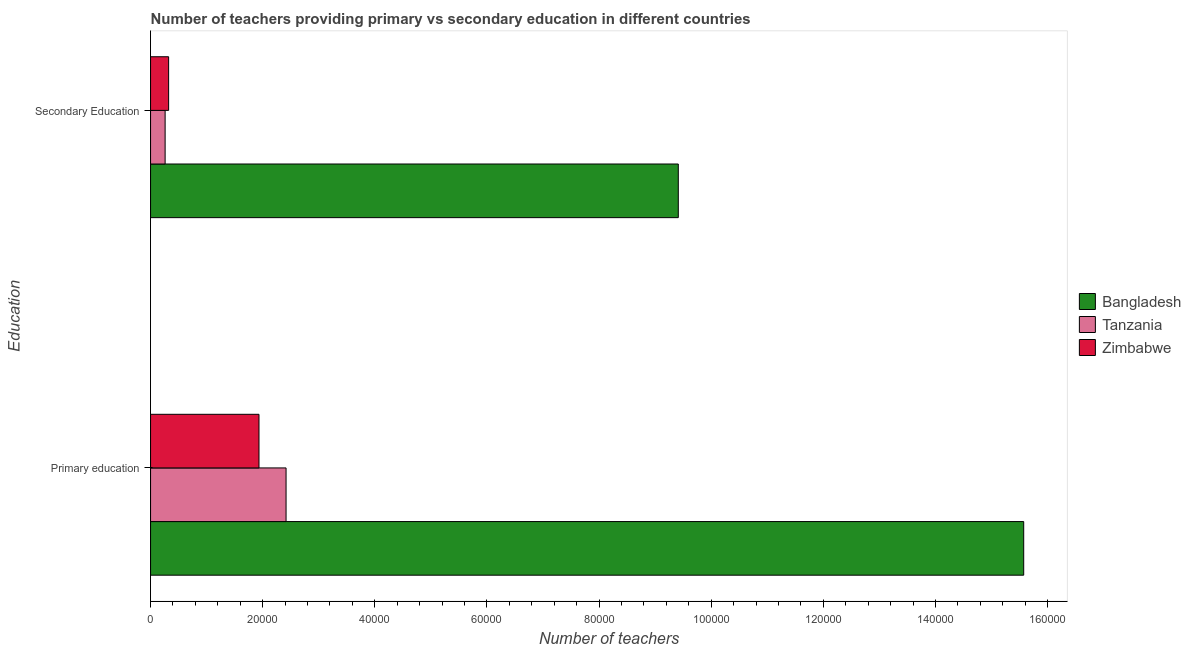How many different coloured bars are there?
Ensure brevity in your answer.  3. How many groups of bars are there?
Provide a succinct answer. 2. Are the number of bars on each tick of the Y-axis equal?
Give a very brief answer. Yes. What is the label of the 1st group of bars from the top?
Offer a very short reply. Secondary Education. What is the number of secondary teachers in Tanzania?
Ensure brevity in your answer.  2596. Across all countries, what is the maximum number of secondary teachers?
Provide a succinct answer. 9.41e+04. Across all countries, what is the minimum number of primary teachers?
Your response must be concise. 1.93e+04. In which country was the number of secondary teachers minimum?
Provide a short and direct response. Tanzania. What is the total number of secondary teachers in the graph?
Make the answer very short. 9.99e+04. What is the difference between the number of primary teachers in Tanzania and that in Bangladesh?
Make the answer very short. -1.32e+05. What is the difference between the number of secondary teachers in Zimbabwe and the number of primary teachers in Tanzania?
Make the answer very short. -2.09e+04. What is the average number of secondary teachers per country?
Keep it short and to the point. 3.33e+04. What is the difference between the number of secondary teachers and number of primary teachers in Tanzania?
Provide a succinct answer. -2.16e+04. What is the ratio of the number of primary teachers in Bangladesh to that in Zimbabwe?
Ensure brevity in your answer.  8.05. In how many countries, is the number of primary teachers greater than the average number of primary teachers taken over all countries?
Provide a short and direct response. 1. What does the 2nd bar from the top in Primary education represents?
Provide a short and direct response. Tanzania. How many bars are there?
Ensure brevity in your answer.  6. Are all the bars in the graph horizontal?
Your answer should be very brief. Yes. How many legend labels are there?
Your answer should be compact. 3. What is the title of the graph?
Give a very brief answer. Number of teachers providing primary vs secondary education in different countries. What is the label or title of the X-axis?
Your answer should be very brief. Number of teachers. What is the label or title of the Y-axis?
Offer a terse response. Education. What is the Number of teachers of Bangladesh in Primary education?
Your answer should be very brief. 1.56e+05. What is the Number of teachers of Tanzania in Primary education?
Offer a terse response. 2.42e+04. What is the Number of teachers of Zimbabwe in Primary education?
Your answer should be compact. 1.93e+04. What is the Number of teachers in Bangladesh in Secondary Education?
Offer a terse response. 9.41e+04. What is the Number of teachers in Tanzania in Secondary Education?
Your answer should be compact. 2596. What is the Number of teachers of Zimbabwe in Secondary Education?
Provide a short and direct response. 3221. Across all Education, what is the maximum Number of teachers of Bangladesh?
Your answer should be very brief. 1.56e+05. Across all Education, what is the maximum Number of teachers of Tanzania?
Offer a terse response. 2.42e+04. Across all Education, what is the maximum Number of teachers in Zimbabwe?
Offer a terse response. 1.93e+04. Across all Education, what is the minimum Number of teachers in Bangladesh?
Provide a succinct answer. 9.41e+04. Across all Education, what is the minimum Number of teachers in Tanzania?
Ensure brevity in your answer.  2596. Across all Education, what is the minimum Number of teachers in Zimbabwe?
Your answer should be very brief. 3221. What is the total Number of teachers of Bangladesh in the graph?
Your response must be concise. 2.50e+05. What is the total Number of teachers of Tanzania in the graph?
Ensure brevity in your answer.  2.68e+04. What is the total Number of teachers of Zimbabwe in the graph?
Your response must be concise. 2.26e+04. What is the difference between the Number of teachers in Bangladesh in Primary education and that in Secondary Education?
Provide a succinct answer. 6.16e+04. What is the difference between the Number of teachers in Tanzania in Primary education and that in Secondary Education?
Your answer should be compact. 2.16e+04. What is the difference between the Number of teachers of Zimbabwe in Primary education and that in Secondary Education?
Your response must be concise. 1.61e+04. What is the difference between the Number of teachers in Bangladesh in Primary education and the Number of teachers in Tanzania in Secondary Education?
Offer a very short reply. 1.53e+05. What is the difference between the Number of teachers of Bangladesh in Primary education and the Number of teachers of Zimbabwe in Secondary Education?
Your answer should be very brief. 1.53e+05. What is the difference between the Number of teachers of Tanzania in Primary education and the Number of teachers of Zimbabwe in Secondary Education?
Offer a very short reply. 2.09e+04. What is the average Number of teachers in Bangladesh per Education?
Offer a terse response. 1.25e+05. What is the average Number of teachers of Tanzania per Education?
Keep it short and to the point. 1.34e+04. What is the average Number of teachers in Zimbabwe per Education?
Your answer should be very brief. 1.13e+04. What is the difference between the Number of teachers in Bangladesh and Number of teachers in Tanzania in Primary education?
Provide a short and direct response. 1.32e+05. What is the difference between the Number of teachers of Bangladesh and Number of teachers of Zimbabwe in Primary education?
Your answer should be very brief. 1.36e+05. What is the difference between the Number of teachers in Tanzania and Number of teachers in Zimbabwe in Primary education?
Your answer should be very brief. 4830. What is the difference between the Number of teachers in Bangladesh and Number of teachers in Tanzania in Secondary Education?
Your response must be concise. 9.15e+04. What is the difference between the Number of teachers in Bangladesh and Number of teachers in Zimbabwe in Secondary Education?
Give a very brief answer. 9.09e+04. What is the difference between the Number of teachers in Tanzania and Number of teachers in Zimbabwe in Secondary Education?
Make the answer very short. -625. What is the ratio of the Number of teachers of Bangladesh in Primary education to that in Secondary Education?
Ensure brevity in your answer.  1.65. What is the ratio of the Number of teachers in Tanzania in Primary education to that in Secondary Education?
Provide a succinct answer. 9.31. What is the ratio of the Number of teachers of Zimbabwe in Primary education to that in Secondary Education?
Give a very brief answer. 6. What is the difference between the highest and the second highest Number of teachers in Bangladesh?
Ensure brevity in your answer.  6.16e+04. What is the difference between the highest and the second highest Number of teachers in Tanzania?
Provide a succinct answer. 2.16e+04. What is the difference between the highest and the second highest Number of teachers in Zimbabwe?
Your response must be concise. 1.61e+04. What is the difference between the highest and the lowest Number of teachers in Bangladesh?
Your answer should be very brief. 6.16e+04. What is the difference between the highest and the lowest Number of teachers of Tanzania?
Your answer should be compact. 2.16e+04. What is the difference between the highest and the lowest Number of teachers of Zimbabwe?
Your answer should be compact. 1.61e+04. 